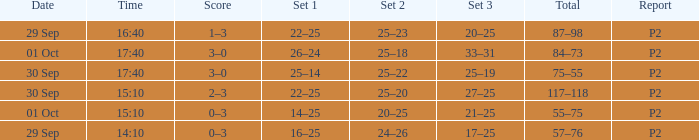What Score has a time of 14:10? 0–3. 